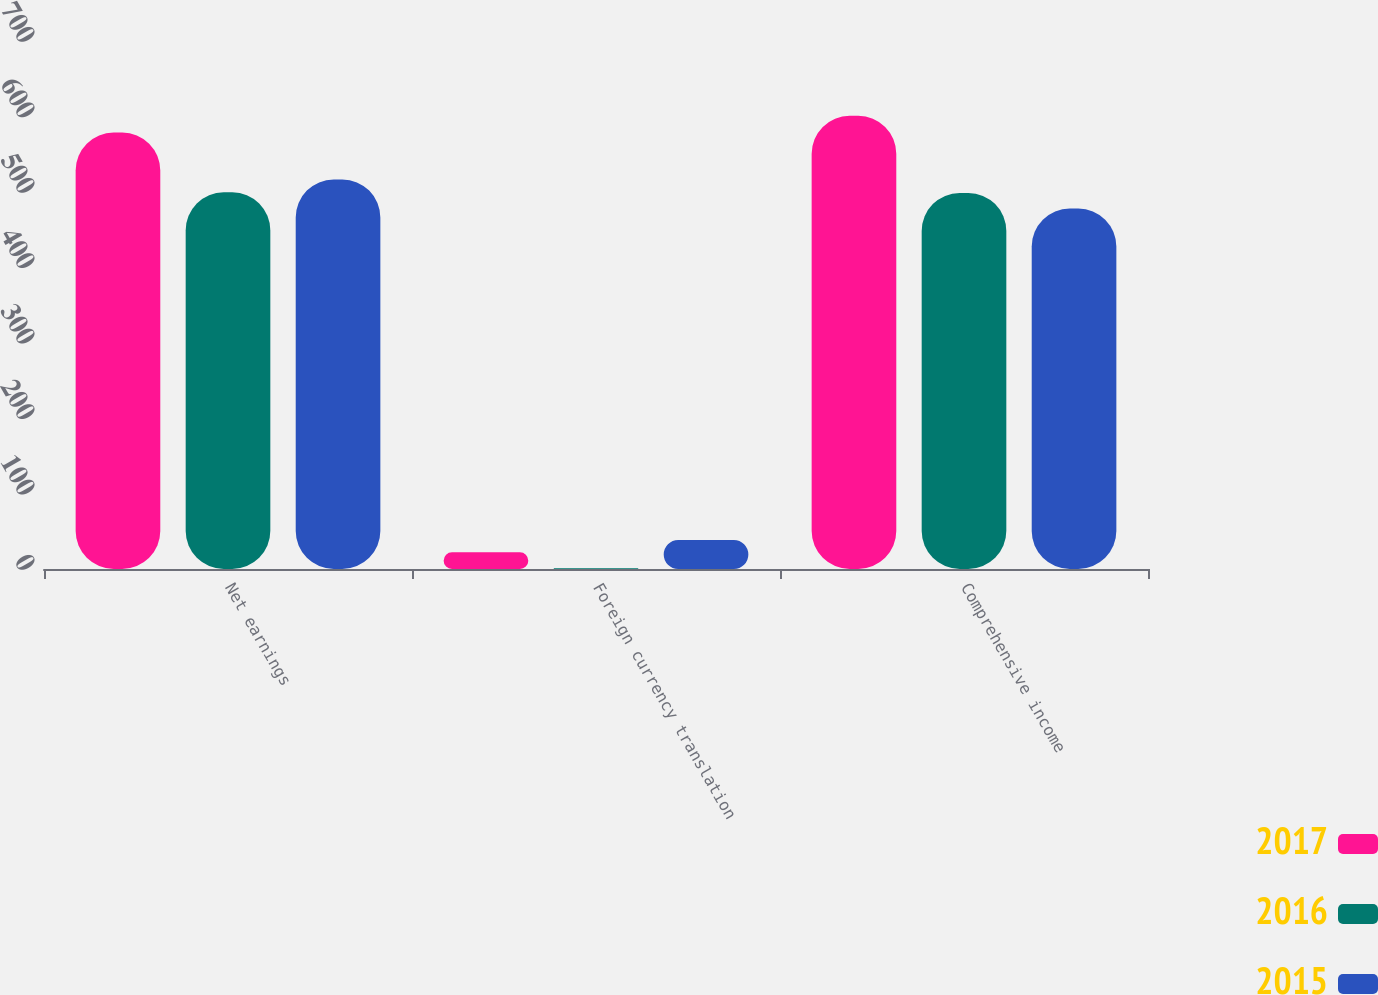Convert chart. <chart><loc_0><loc_0><loc_500><loc_500><stacked_bar_chart><ecel><fcel>Net earnings<fcel>Foreign currency translation<fcel>Comprehensive income<nl><fcel>2017<fcel>578.6<fcel>22.2<fcel>600.8<nl><fcel>2016<fcel>499.4<fcel>0.9<fcel>498.5<nl><fcel>2015<fcel>516.4<fcel>38.6<fcel>477.8<nl></chart> 